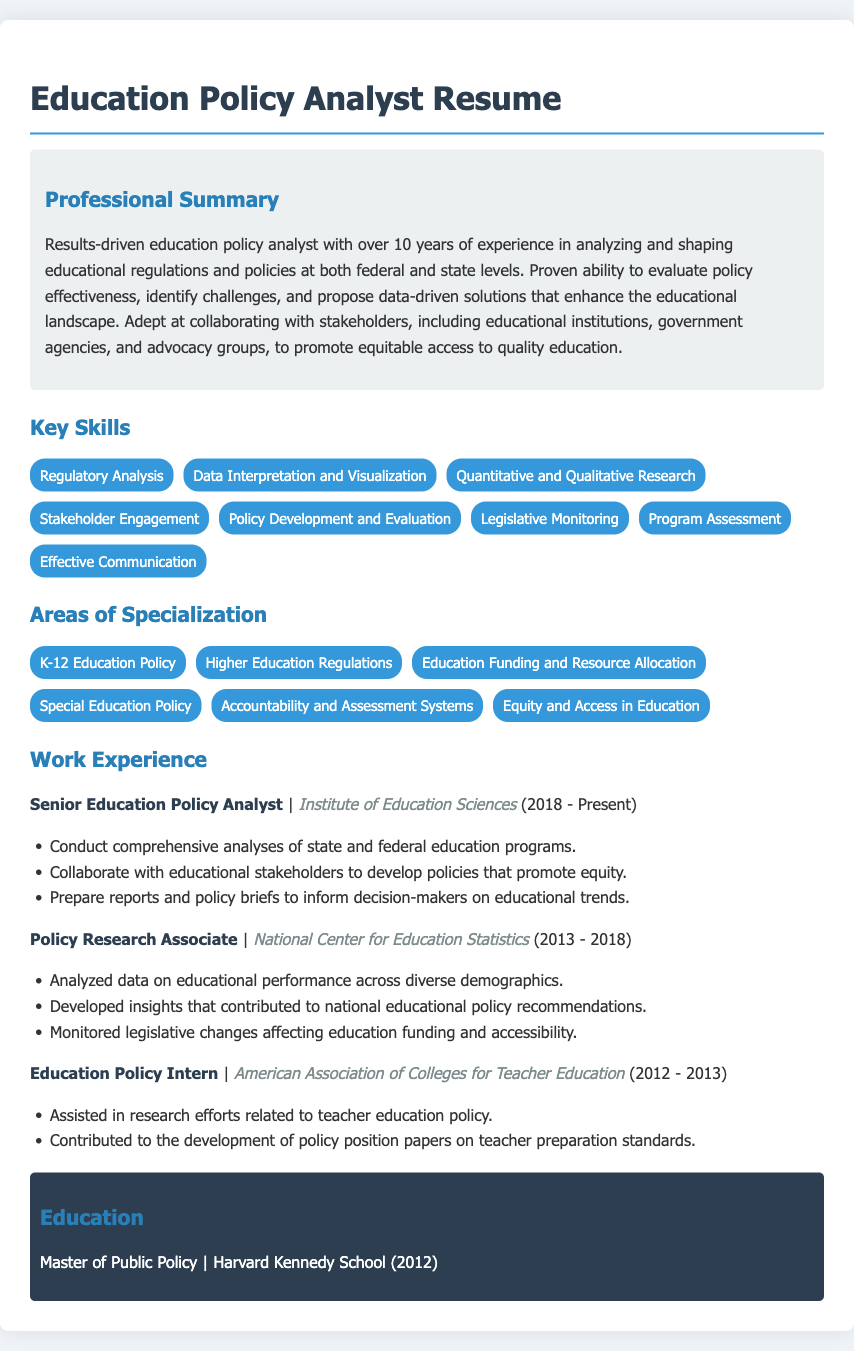What is the total years of experience? The total years of experience mentioned in the document is clearly stated as over 10 years.
Answer: over 10 years What is the job title of the current position? The job title listed for the current position held since 2018 is Senior Education Policy Analyst.
Answer: Senior Education Policy Analyst Which organization is the current job position with? The current job position is with the Institute of Education Sciences.
Answer: Institute of Education Sciences What area of specialization focuses on educational equity? One of the areas of specialization explicitly mentioned is Equity and Access in Education.
Answer: Equity and Access in Education What key skill involves interaction with various stakeholders? The skill that involves engaging with different stakeholders is Stakeholder Engagement.
Answer: Stakeholder Engagement In what year did the candidate start working at the National Center for Education Statistics? The candidate started working at the National Center for Education Statistics in 2013.
Answer: 2013 Which position was held before becoming a Senior Education Policy Analyst? The position held before the current one was Policy Research Associate.
Answer: Policy Research Associate 